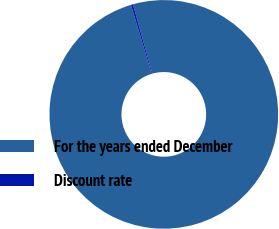Convert chart. <chart><loc_0><loc_0><loc_500><loc_500><pie_chart><fcel>For the years ended December<fcel>Discount rate<nl><fcel>99.73%<fcel>0.27%<nl></chart> 